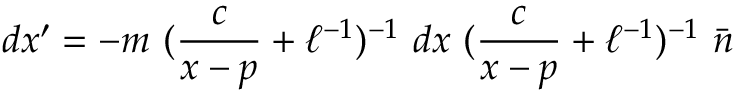Convert formula to latex. <formula><loc_0><loc_0><loc_500><loc_500>d x ^ { \prime } = - m ( \frac { c } { x - p } + \ell ^ { - 1 } ) ^ { - 1 } d x ( \frac { c } { x - p } + \ell ^ { - 1 } ) ^ { - 1 } \bar { n }</formula> 